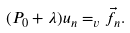<formula> <loc_0><loc_0><loc_500><loc_500>( P _ { 0 } + \lambda ) u _ { n } = _ { v } \vec { f } _ { n } .</formula> 